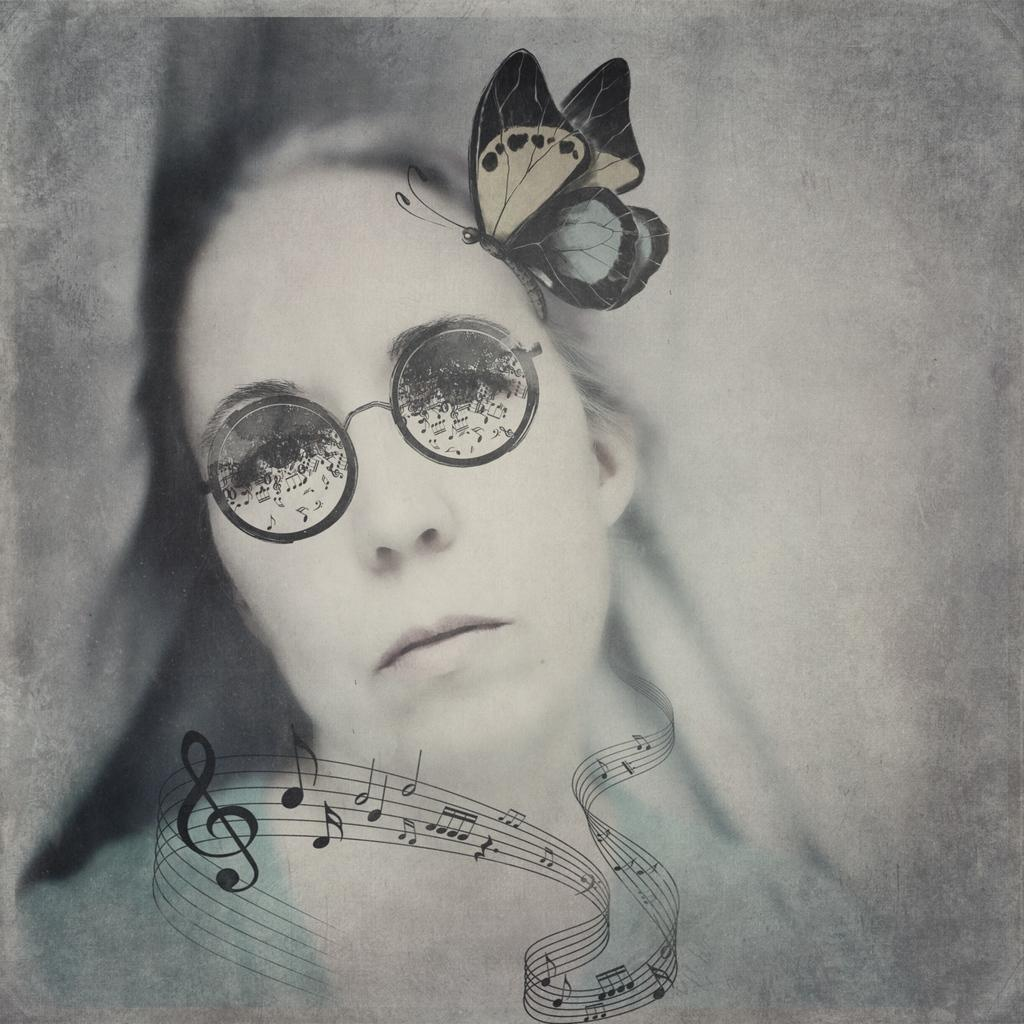Who is present in the image? There is a woman in the image. What is the woman wearing on her face? The woman is wearing goggles. What type of insect can be seen in the image? There is a butterfly in the image. What colors are present on the butterfly? The butterfly is black, cream, and blue in color. What type of lines are visible in the image? There are black colored lines in the image. What type of sack is the woman carrying in the image? There is no sack present in the image. What is the ground like in the image? The ground is not visible in the image, so it cannot be described. 